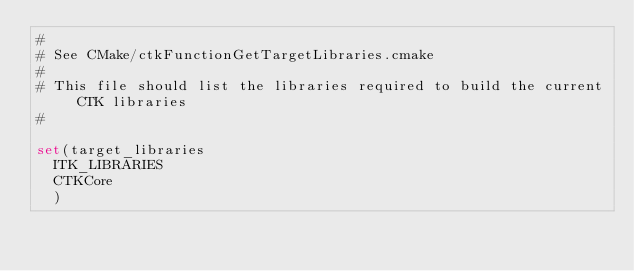Convert code to text. <code><loc_0><loc_0><loc_500><loc_500><_CMake_>#
# See CMake/ctkFunctionGetTargetLibraries.cmake
# 
# This file should list the libraries required to build the current CTK libraries
#

set(target_libraries
  ITK_LIBRARIES
  CTKCore
  )
</code> 